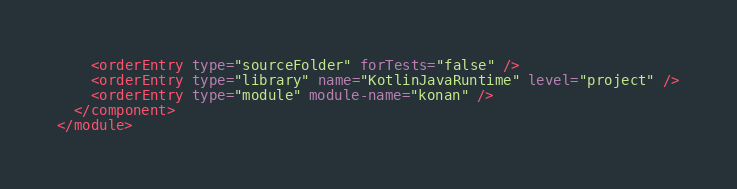<code> <loc_0><loc_0><loc_500><loc_500><_XML_>    <orderEntry type="sourceFolder" forTests="false" />
    <orderEntry type="library" name="KotlinJavaRuntime" level="project" />
    <orderEntry type="module" module-name="konan" />
  </component>
</module></code> 